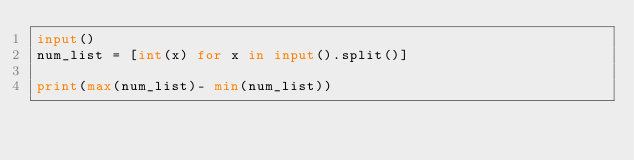<code> <loc_0><loc_0><loc_500><loc_500><_Python_>input()
num_list = [int(x) for x in input().split()]

print(max(num_list)- min(num_list))</code> 